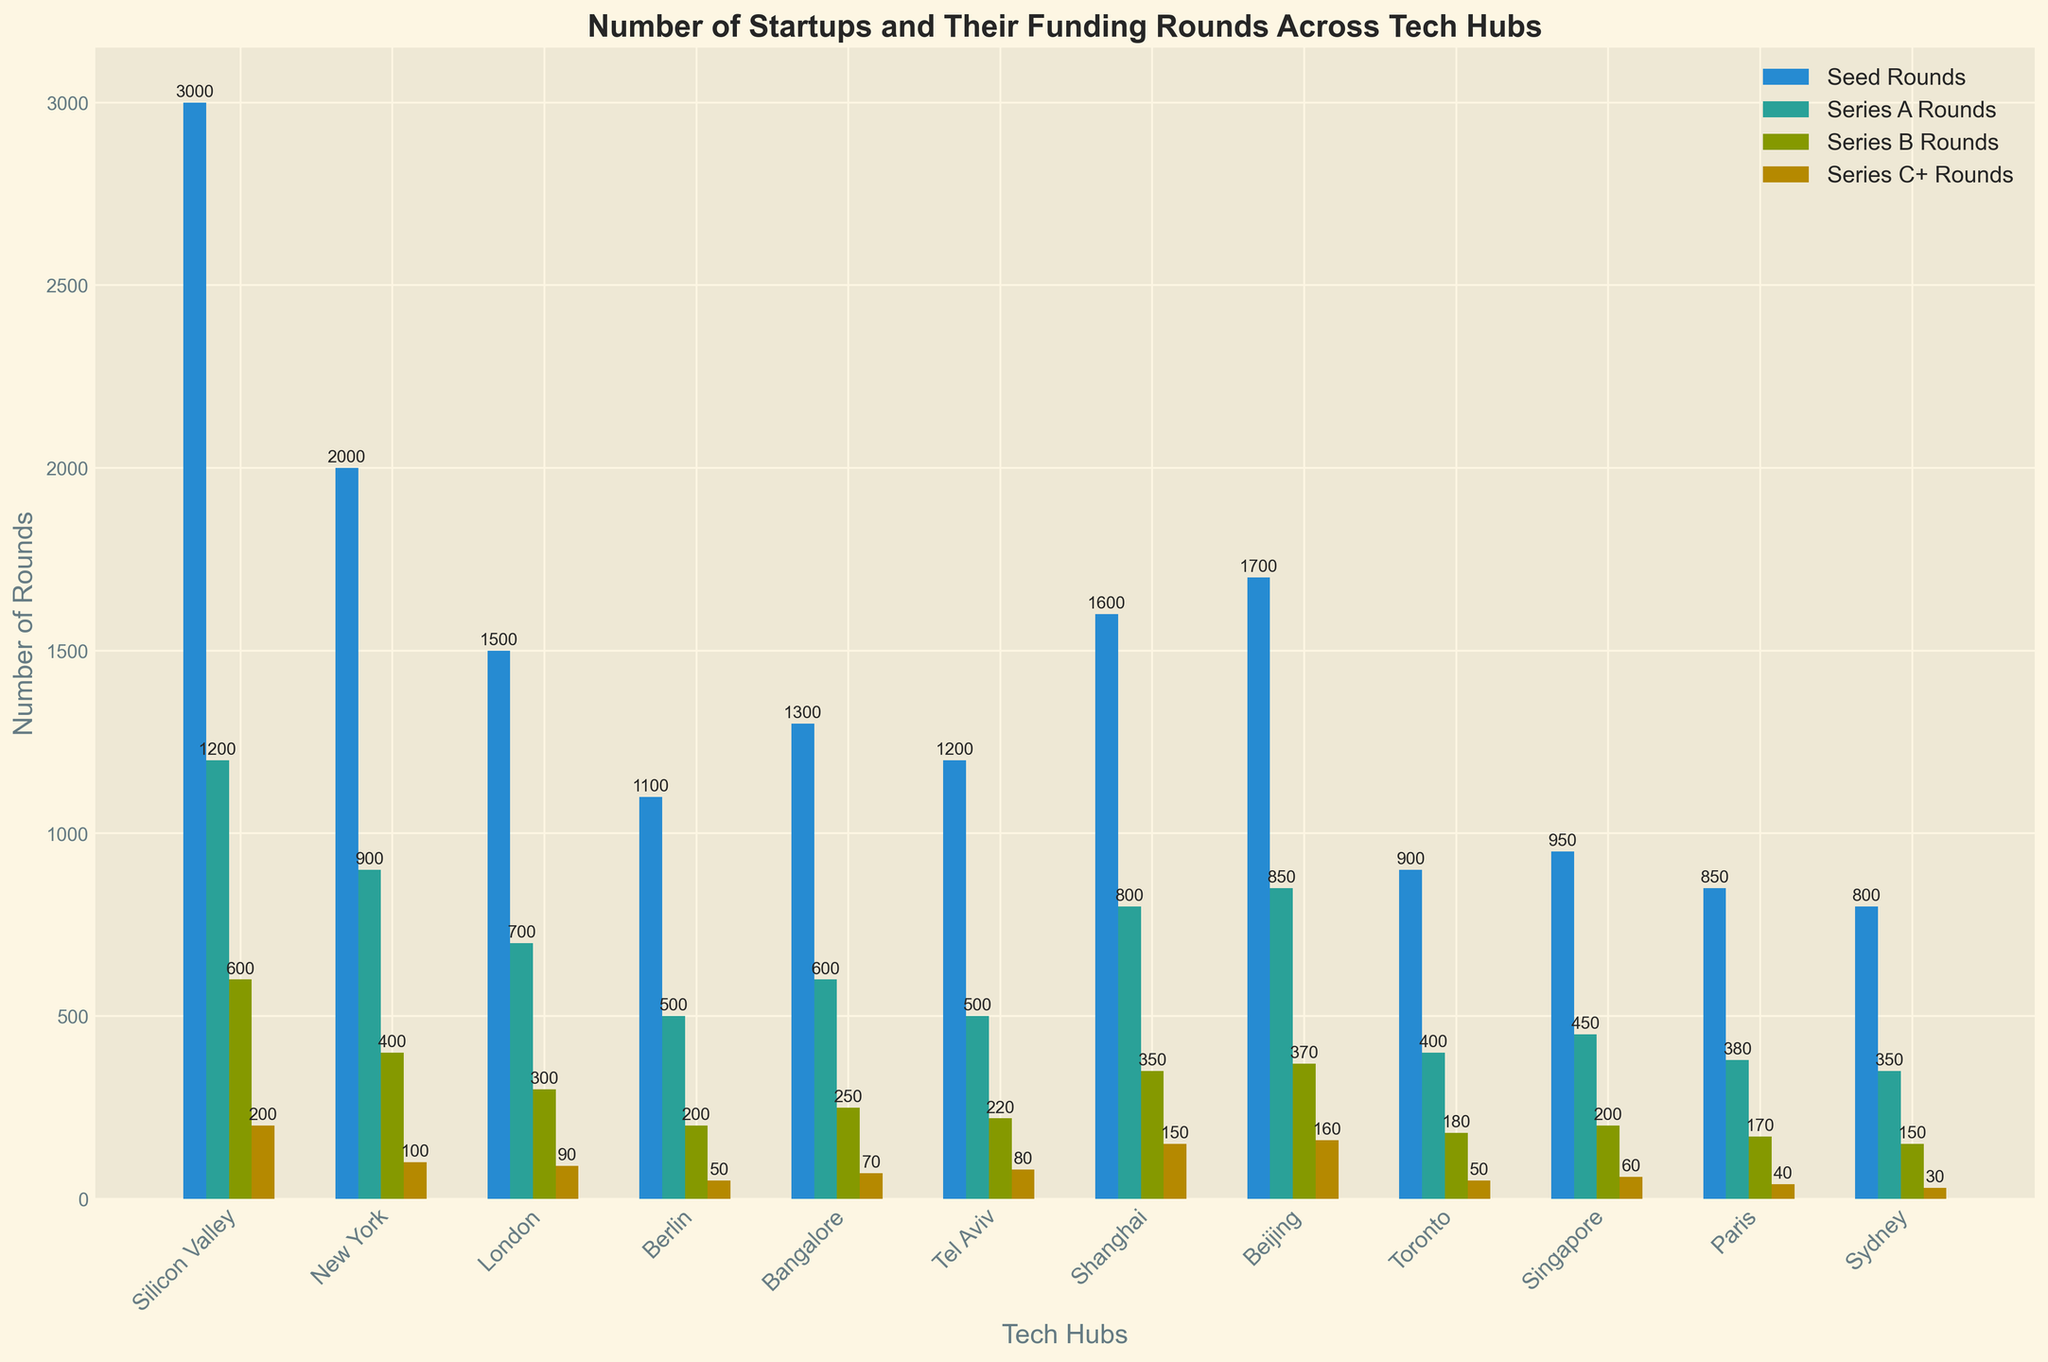Which tech hub has the highest number of startups? The tech hub with the highest bar in the "Number of Startups" series corresponds to Silicon Valley.
Answer: Silicon Valley How many more Series A Rounds than Series C+ Rounds are there in London? The Series A Rounds in London are 700, while the Series C+ Rounds are 90. Subtracting 90 from 700 gives the difference.
Answer: 610 Compare the total funding rounds (Seed, Series A, Series B, Series C+) between Bangalore and Berlin. Which is higher and by how much? Summing the funding rounds for each tech hub: Bangalore has 1300 + 600 + 250 + 70 = 2220; Berlin has 1100 + 500 + 200 + 50 = 1850. The difference is 2220 - 1850.
Answer: Bangalore, 370 What is the average number of Seed Rounds across all tech hubs? Summing the Seed Rounds: 3000 + 2000 + 1500 + 1100 + 1300 + 1200 + 1600 + 1700 + 900 + 950 + 850 + 800 = 18100. Dividing by the number of tech hubs (12) gives the average: 18100 / 12.
Answer: 1508.33 Which tech hub has the highest number of Series B Rounds, and how many does it have? By comparing the heights of the Series B Rounds bars, Silicon Valley has the highest number at 600.
Answer: Silicon Valley, 600 Among the tech hubs with the fewest Series C+ Rounds, are there any that have the same number of such rounds? By comparing the Series C+ Rounds, both Berlin and Toronto have 50 Series C+ Rounds.
Answer: Berlin, Toronto In terms of the total number of funding rounds (Seed, Series A, Series B, Series C+), which tech hub ranks third? Calculating and comparing all totals: 
Silicon Valley: 5000 
New York: 3200 
London: 2500 
Berlin: 1800 
Bangalore: 2200 
Tel Aviv: 2000 
Shanghai: 2700 
Beijing: 2900 
Toronto: 1500 
Singapore: 1600 
Paris: 1400 
Sydney: 1300.
Beijing stands third with 2900.
Answer: Beijing Which tech hub has a greater number of Series A Rounds: Tel Aviv or Singapore? The bar for Series A Rounds shows Tel Aviv has 500 Series A Rounds, and Singapore has 450.
Answer: Tel Aviv Of the tech hubs listed, which has the shortest bar in the Series C+ Rounds category? The shortest bar in the Series C+ Rounds category is for Sydney, which has 30 Series C+ Rounds.
Answer: Sydney 